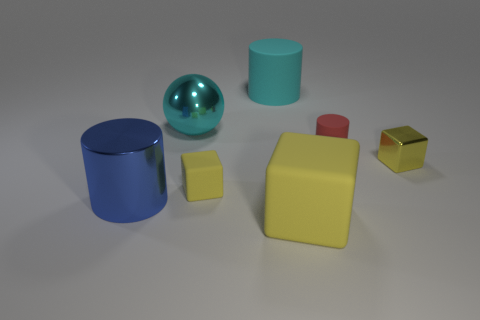How many yellow cubes must be subtracted to get 1 yellow cubes? 2 Subtract all big rubber cylinders. How many cylinders are left? 2 Subtract 1 cubes. How many cubes are left? 2 Add 2 blue shiny cylinders. How many objects exist? 9 Subtract all yellow cylinders. Subtract all blue balls. How many cylinders are left? 3 Subtract all spheres. How many objects are left? 6 Subtract all yellow metallic cubes. Subtract all small yellow shiny objects. How many objects are left? 5 Add 7 cyan rubber objects. How many cyan rubber objects are left? 8 Add 1 big blue cylinders. How many big blue cylinders exist? 2 Subtract 1 red cylinders. How many objects are left? 6 